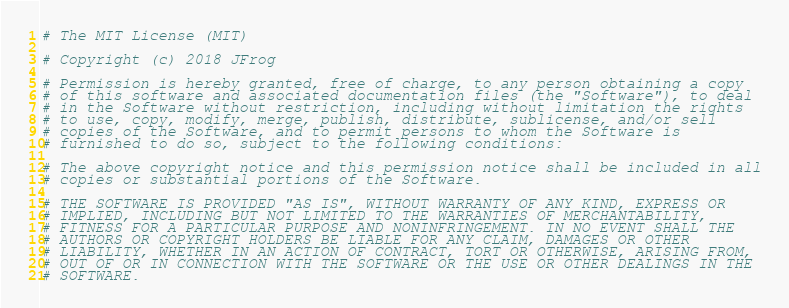Convert code to text. <code><loc_0><loc_0><loc_500><loc_500><_CMake_># The MIT License (MIT)

# Copyright (c) 2018 JFrog

# Permission is hereby granted, free of charge, to any person obtaining a copy
# of this software and associated documentation files (the "Software"), to deal
# in the Software without restriction, including without limitation the rights
# to use, copy, modify, merge, publish, distribute, sublicense, and/or sell
# copies of the Software, and to permit persons to whom the Software is
# furnished to do so, subject to the following conditions:

# The above copyright notice and this permission notice shall be included in all
# copies or substantial portions of the Software.

# THE SOFTWARE IS PROVIDED "AS IS", WITHOUT WARRANTY OF ANY KIND, EXPRESS OR
# IMPLIED, INCLUDING BUT NOT LIMITED TO THE WARRANTIES OF MERCHANTABILITY,
# FITNESS FOR A PARTICULAR PURPOSE AND NONINFRINGEMENT. IN NO EVENT SHALL THE
# AUTHORS OR COPYRIGHT HOLDERS BE LIABLE FOR ANY CLAIM, DAMAGES OR OTHER
# LIABILITY, WHETHER IN AN ACTION OF CONTRACT, TORT OR OTHERWISE, ARISING FROM,
# OUT OF OR IN CONNECTION WITH THE SOFTWARE OR THE USE OR OTHER DEALINGS IN THE
# SOFTWARE.

</code> 